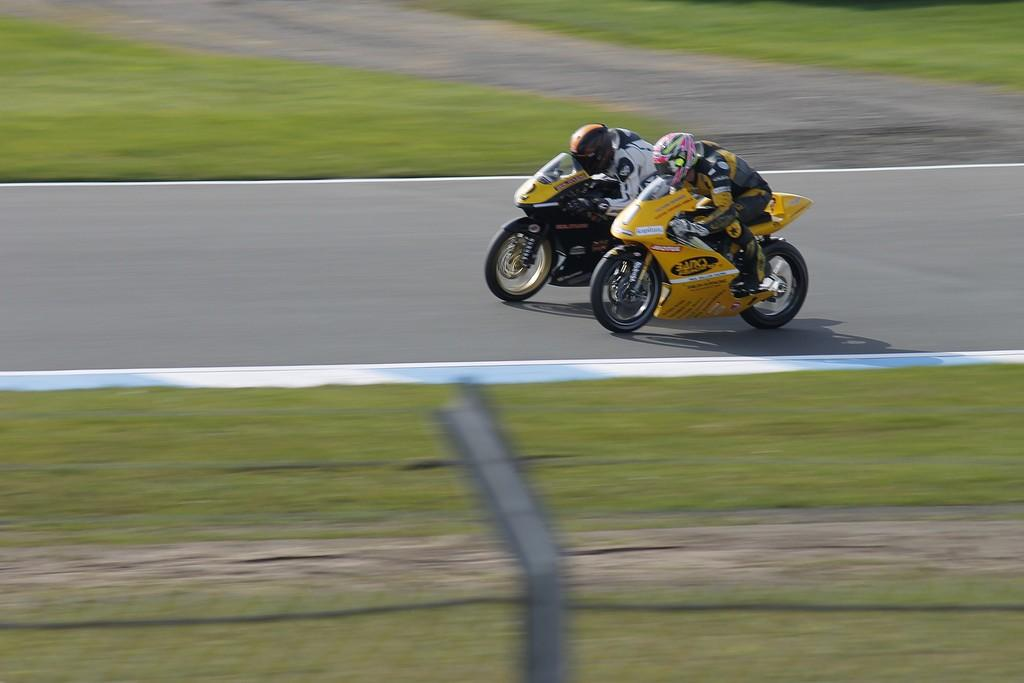How many people are in the image? There are two persons in the image. What are the persons doing in the image? The persons are sitting on bikes and riding on the road. What can be seen on both sides of the road? There is grassland on both sides of the road. What object is visible in the front side of the image? There is a pole visible in the front side of the image. What type of wax can be seen melting on the road in the image? There is no wax present in the image; it features two persons riding bikes on a road with grassland on both sides and a pole visible in the front side. 